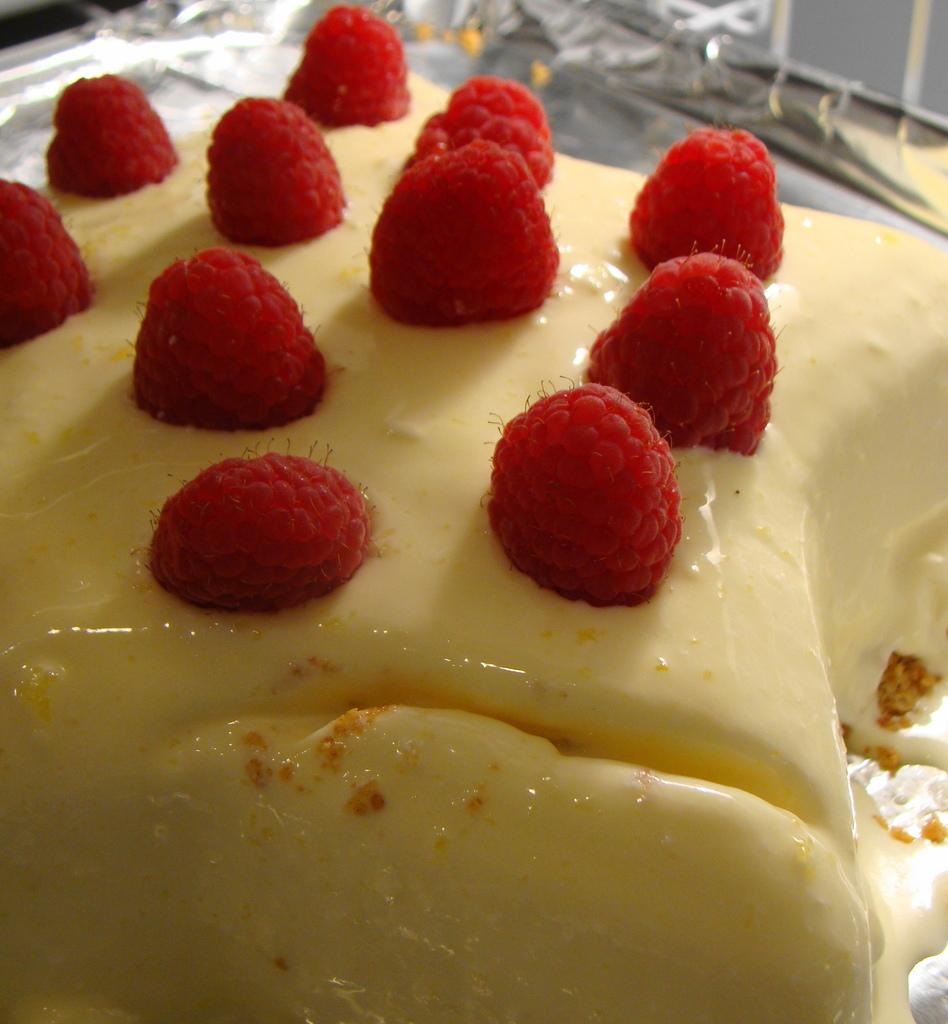What types of objects can be seen in the picture? There are food items in the picture. Can you describe the food items in the picture? Unfortunately, the specific food items cannot be identified without more information. Are there any other objects or elements in the picture besides the food items? The provided facts do not mention any other objects or elements in the picture. What type of house is visible in the background of the picture? There is no house present in the picture; it only contains food items. Can you tell me the size of the ring on the table in the picture? There is no ring present in the picture; it only contains food items. 